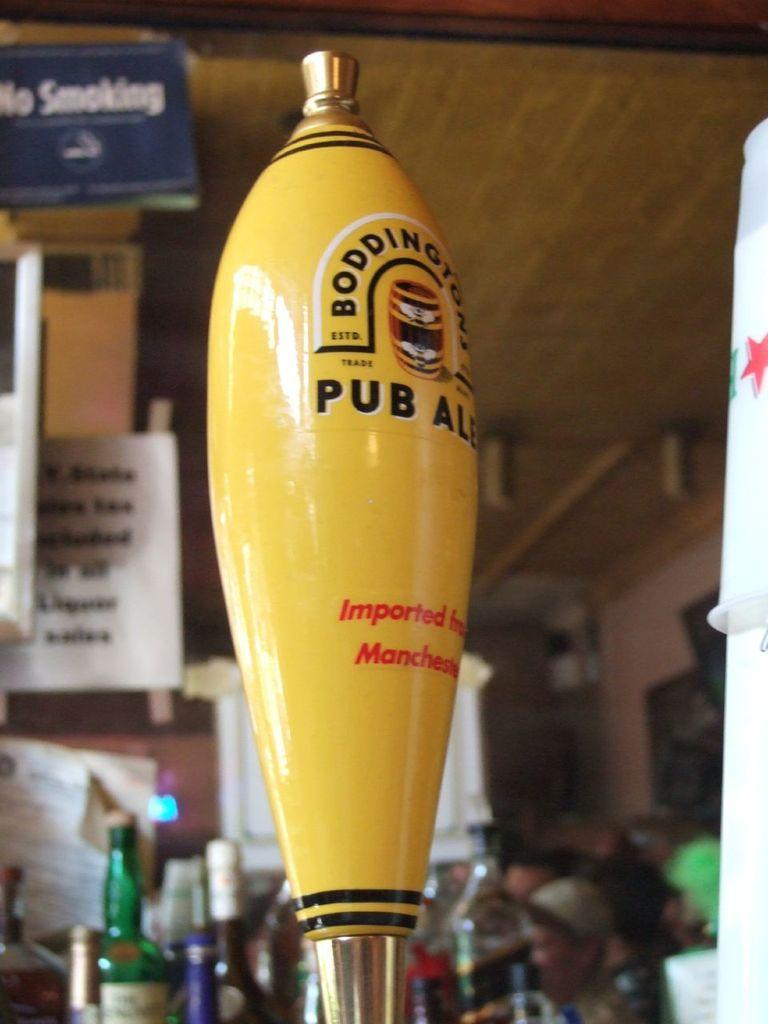<image>
Write a terse but informative summary of the picture. A beer tap handle indicates the ale was imported from Manchester. 